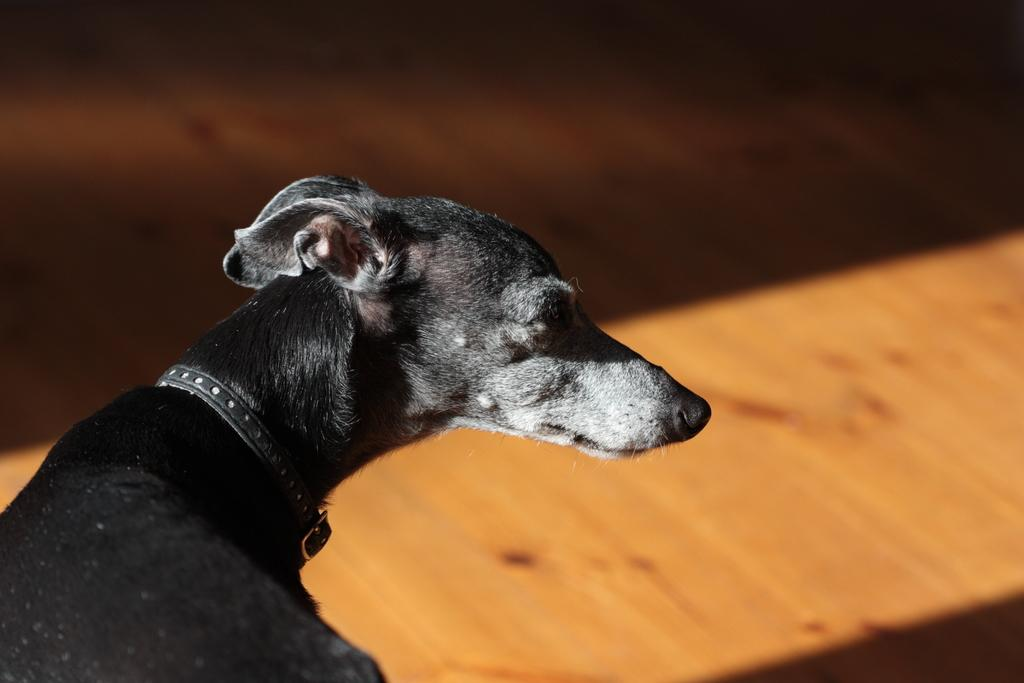What type of animal is in the image? There is a black color dog in the image. Is there anything around the dog's neck? Yes, the dog has a black color belt around its neck. What type of flooring is visible in the image? There is a wooden floor in front of the dog. How many babies are sitting on the wooden floor with the dog in the image? There are no babies present in the image; it only features a black color dog with a belt around its neck on a wooden floor. 